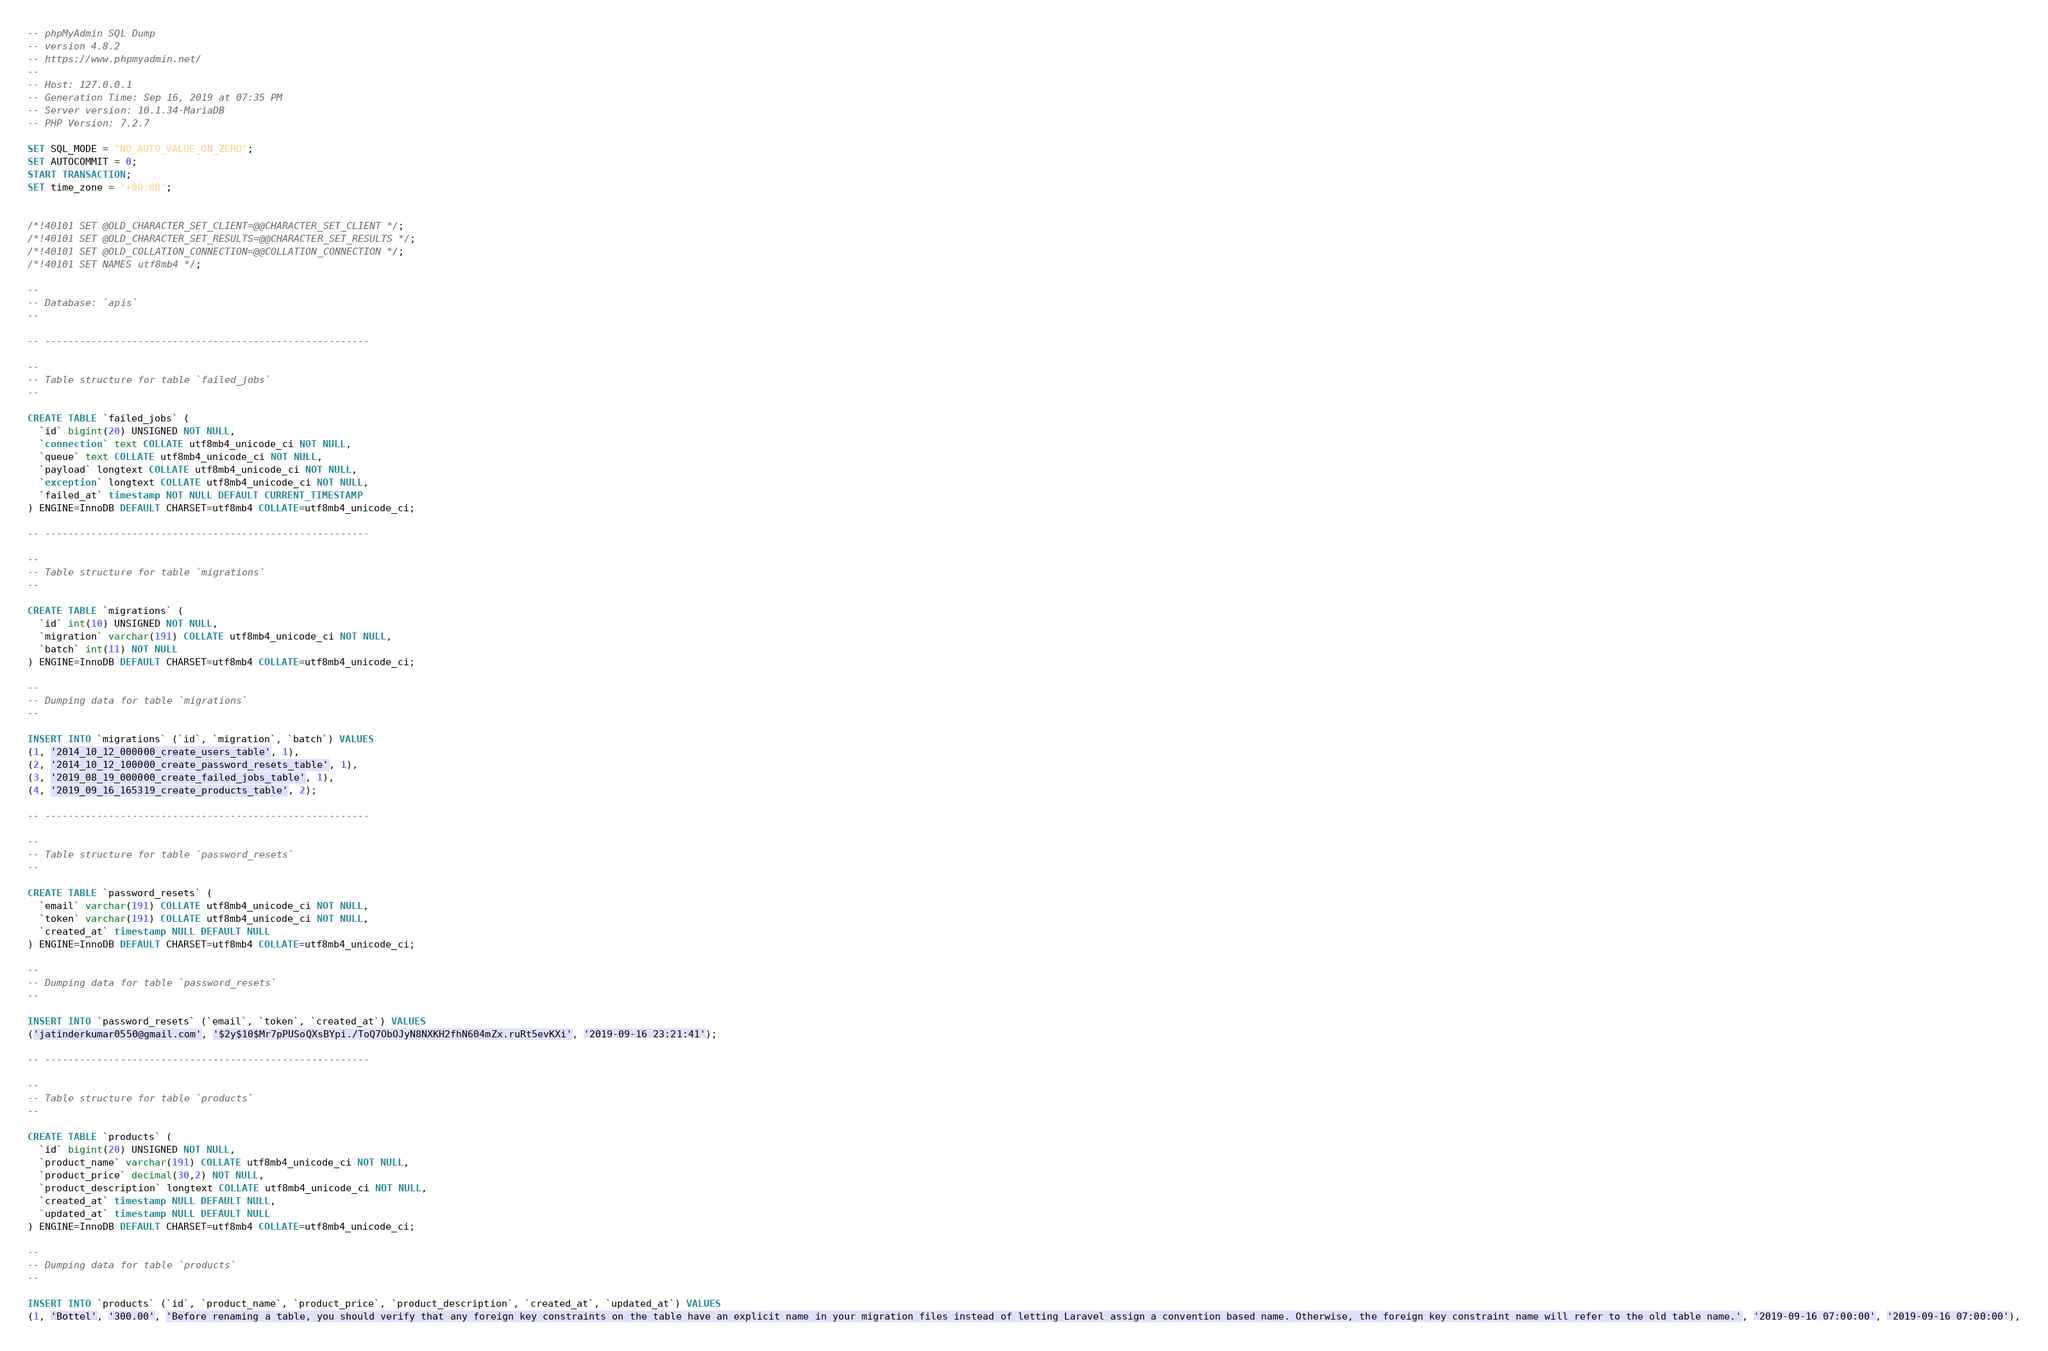Convert code to text. <code><loc_0><loc_0><loc_500><loc_500><_SQL_>-- phpMyAdmin SQL Dump
-- version 4.8.2
-- https://www.phpmyadmin.net/
--
-- Host: 127.0.0.1
-- Generation Time: Sep 16, 2019 at 07:35 PM
-- Server version: 10.1.34-MariaDB
-- PHP Version: 7.2.7

SET SQL_MODE = "NO_AUTO_VALUE_ON_ZERO";
SET AUTOCOMMIT = 0;
START TRANSACTION;
SET time_zone = "+00:00";


/*!40101 SET @OLD_CHARACTER_SET_CLIENT=@@CHARACTER_SET_CLIENT */;
/*!40101 SET @OLD_CHARACTER_SET_RESULTS=@@CHARACTER_SET_RESULTS */;
/*!40101 SET @OLD_COLLATION_CONNECTION=@@COLLATION_CONNECTION */;
/*!40101 SET NAMES utf8mb4 */;

--
-- Database: `apis`
--

-- --------------------------------------------------------

--
-- Table structure for table `failed_jobs`
--

CREATE TABLE `failed_jobs` (
  `id` bigint(20) UNSIGNED NOT NULL,
  `connection` text COLLATE utf8mb4_unicode_ci NOT NULL,
  `queue` text COLLATE utf8mb4_unicode_ci NOT NULL,
  `payload` longtext COLLATE utf8mb4_unicode_ci NOT NULL,
  `exception` longtext COLLATE utf8mb4_unicode_ci NOT NULL,
  `failed_at` timestamp NOT NULL DEFAULT CURRENT_TIMESTAMP
) ENGINE=InnoDB DEFAULT CHARSET=utf8mb4 COLLATE=utf8mb4_unicode_ci;

-- --------------------------------------------------------

--
-- Table structure for table `migrations`
--

CREATE TABLE `migrations` (
  `id` int(10) UNSIGNED NOT NULL,
  `migration` varchar(191) COLLATE utf8mb4_unicode_ci NOT NULL,
  `batch` int(11) NOT NULL
) ENGINE=InnoDB DEFAULT CHARSET=utf8mb4 COLLATE=utf8mb4_unicode_ci;

--
-- Dumping data for table `migrations`
--

INSERT INTO `migrations` (`id`, `migration`, `batch`) VALUES
(1, '2014_10_12_000000_create_users_table', 1),
(2, '2014_10_12_100000_create_password_resets_table', 1),
(3, '2019_08_19_000000_create_failed_jobs_table', 1),
(4, '2019_09_16_165319_create_products_table', 2);

-- --------------------------------------------------------

--
-- Table structure for table `password_resets`
--

CREATE TABLE `password_resets` (
  `email` varchar(191) COLLATE utf8mb4_unicode_ci NOT NULL,
  `token` varchar(191) COLLATE utf8mb4_unicode_ci NOT NULL,
  `created_at` timestamp NULL DEFAULT NULL
) ENGINE=InnoDB DEFAULT CHARSET=utf8mb4 COLLATE=utf8mb4_unicode_ci;

--
-- Dumping data for table `password_resets`
--

INSERT INTO `password_resets` (`email`, `token`, `created_at`) VALUES
('jatinderkumar0550@gmail.com', '$2y$10$Mr7pPUSoQXsBYpi./ToQ7ObOJyN8NXKH2fhN604mZx.ruRt5evKXi', '2019-09-16 23:21:41');

-- --------------------------------------------------------

--
-- Table structure for table `products`
--

CREATE TABLE `products` (
  `id` bigint(20) UNSIGNED NOT NULL,
  `product_name` varchar(191) COLLATE utf8mb4_unicode_ci NOT NULL,
  `product_price` decimal(30,2) NOT NULL,
  `product_description` longtext COLLATE utf8mb4_unicode_ci NOT NULL,
  `created_at` timestamp NULL DEFAULT NULL,
  `updated_at` timestamp NULL DEFAULT NULL
) ENGINE=InnoDB DEFAULT CHARSET=utf8mb4 COLLATE=utf8mb4_unicode_ci;

--
-- Dumping data for table `products`
--

INSERT INTO `products` (`id`, `product_name`, `product_price`, `product_description`, `created_at`, `updated_at`) VALUES
(1, 'Bottel', '300.00', 'Before renaming a table, you should verify that any foreign key constraints on the table have an explicit name in your migration files instead of letting Laravel assign a convention based name. Otherwise, the foreign key constraint name will refer to the old table name.', '2019-09-16 07:00:00', '2019-09-16 07:00:00'),</code> 